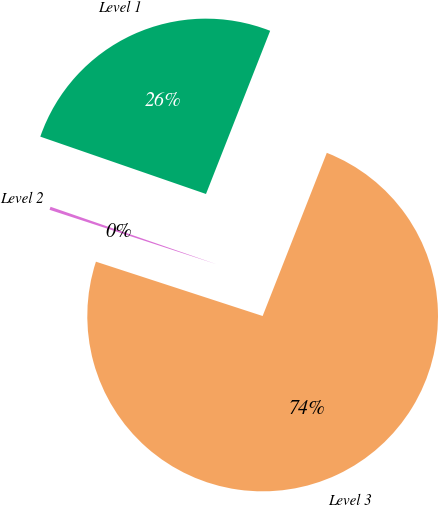Convert chart. <chart><loc_0><loc_0><loc_500><loc_500><pie_chart><fcel>Level 1<fcel>Level 2<fcel>Level 3<nl><fcel>25.66%<fcel>0.29%<fcel>74.05%<nl></chart> 